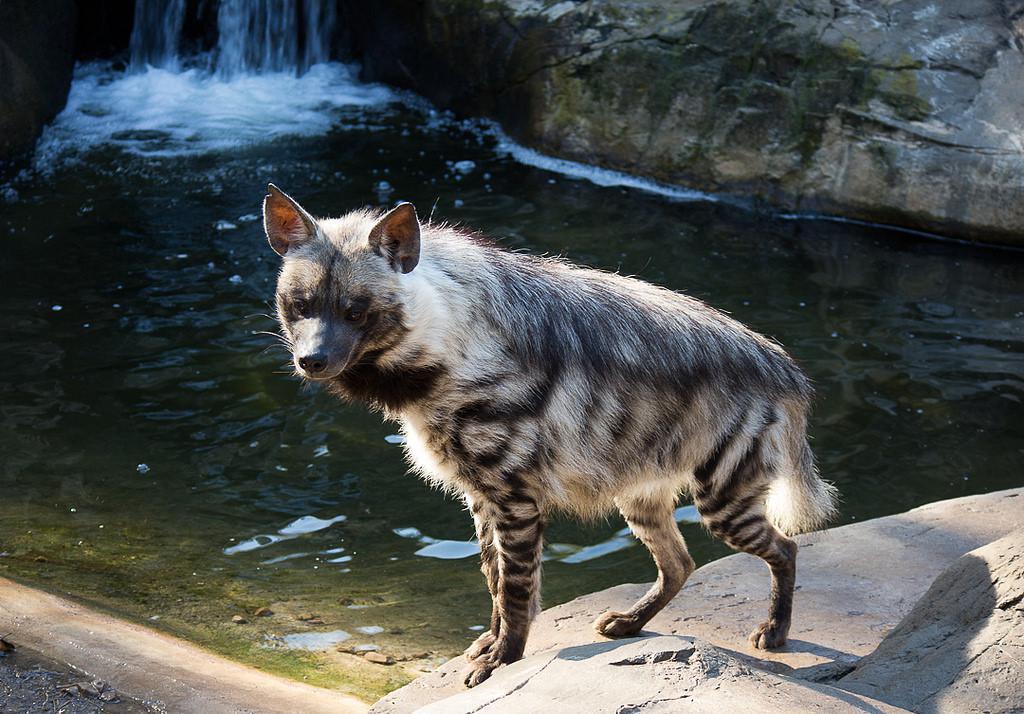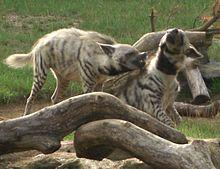The first image is the image on the left, the second image is the image on the right. For the images shown, is this caption "There are two animals in the image on the left." true? Answer yes or no. No. The first image is the image on the left, the second image is the image on the right. For the images displayed, is the sentence "There is only one hyena in the left-hand image." factually correct? Answer yes or no. Yes. 